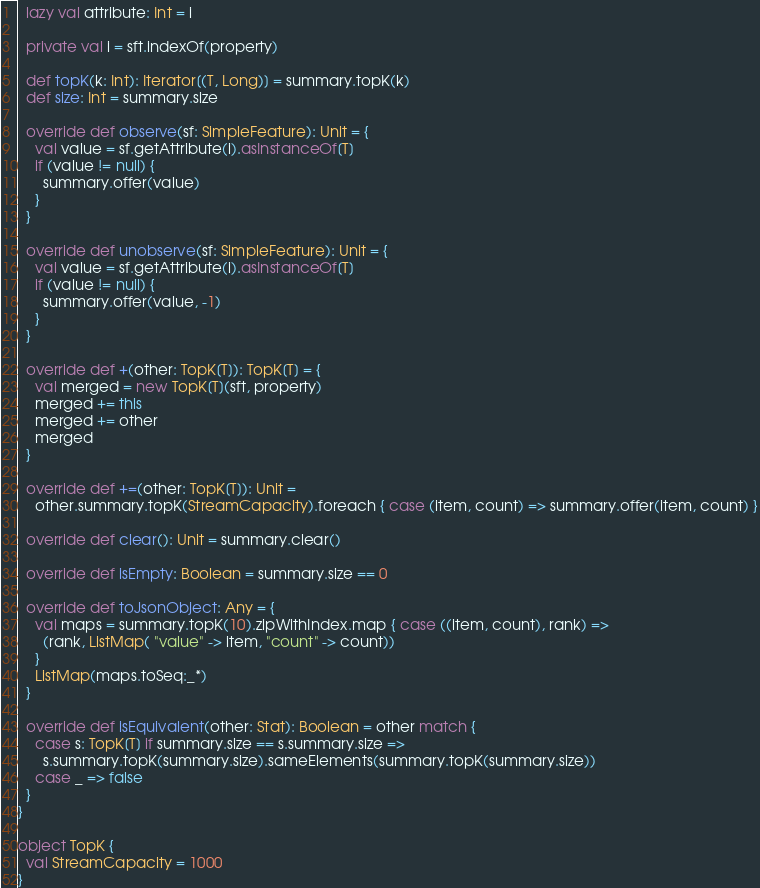Convert code to text. <code><loc_0><loc_0><loc_500><loc_500><_Scala_>  lazy val attribute: Int = i

  private val i = sft.indexOf(property)

  def topK(k: Int): Iterator[(T, Long)] = summary.topK(k)
  def size: Int = summary.size

  override def observe(sf: SimpleFeature): Unit = {
    val value = sf.getAttribute(i).asInstanceOf[T]
    if (value != null) {
      summary.offer(value)
    }
  }

  override def unobserve(sf: SimpleFeature): Unit = {
    val value = sf.getAttribute(i).asInstanceOf[T]
    if (value != null) {
      summary.offer(value, -1)
    }
  }

  override def +(other: TopK[T]): TopK[T] = {
    val merged = new TopK[T](sft, property)
    merged += this
    merged += other
    merged
  }

  override def +=(other: TopK[T]): Unit =
    other.summary.topK(StreamCapacity).foreach { case (item, count) => summary.offer(item, count) }

  override def clear(): Unit = summary.clear()

  override def isEmpty: Boolean = summary.size == 0

  override def toJsonObject: Any = {
    val maps = summary.topK(10).zipWithIndex.map { case ((item, count), rank) =>
      (rank, ListMap( "value" -> item, "count" -> count))
    }
    ListMap(maps.toSeq:_*)
  }

  override def isEquivalent(other: Stat): Boolean = other match {
    case s: TopK[T] if summary.size == s.summary.size =>
      s.summary.topK(summary.size).sameElements(summary.topK(summary.size))
    case _ => false
  }
}

object TopK {
  val StreamCapacity = 1000
}
</code> 